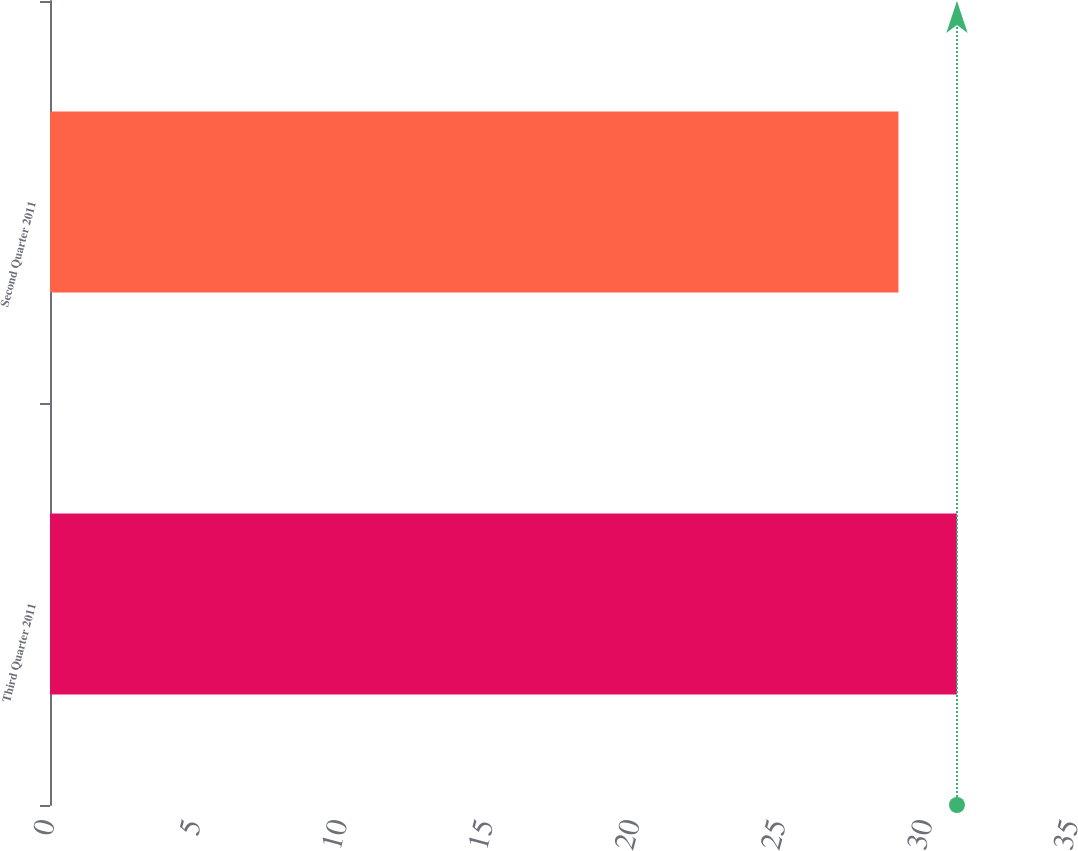Convert chart. <chart><loc_0><loc_0><loc_500><loc_500><bar_chart><fcel>Third Quarter 2011<fcel>Second Quarter 2011<nl><fcel>31<fcel>29<nl></chart> 